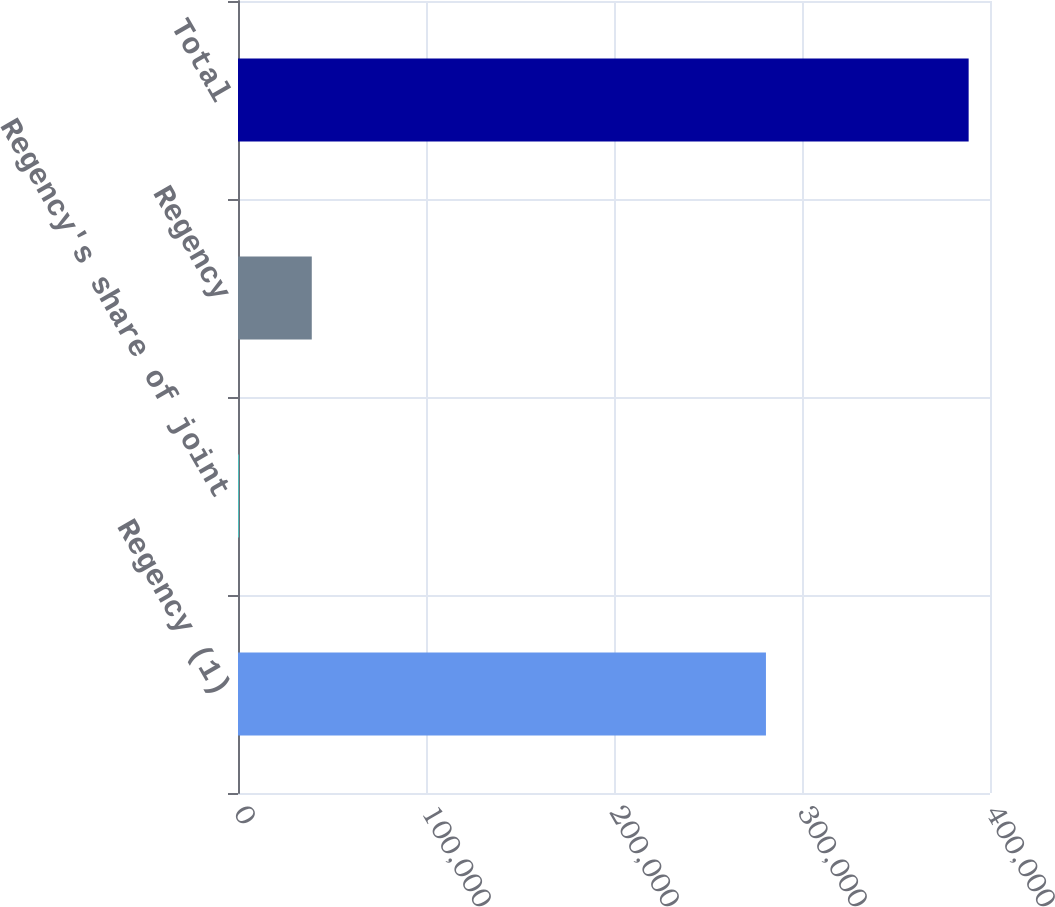Convert chart. <chart><loc_0><loc_0><loc_500><loc_500><bar_chart><fcel>Regency (1)<fcel>Regency's share of joint<fcel>Regency<fcel>Total<nl><fcel>280824<fcel>422<fcel>39244.1<fcel>388643<nl></chart> 